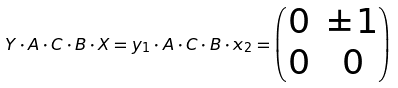<formula> <loc_0><loc_0><loc_500><loc_500>Y \cdot A \cdot C \cdot B \cdot X = y _ { 1 } \cdot A \cdot C \cdot B \cdot x _ { 2 } = \begin{pmatrix} 0 & \pm 1 \\ 0 & 0 \end{pmatrix}</formula> 